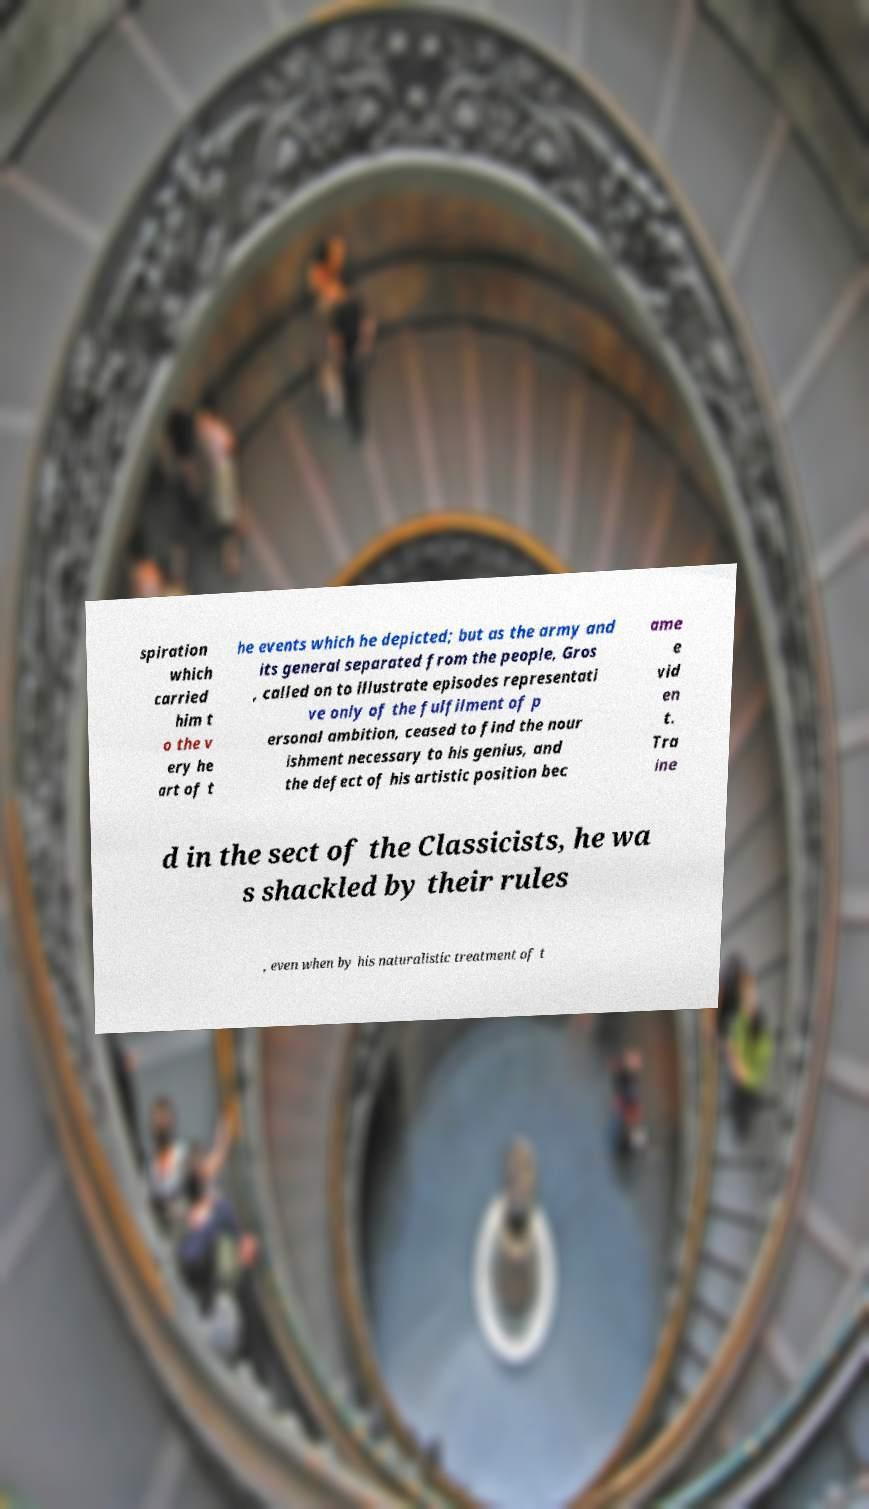Could you extract and type out the text from this image? spiration which carried him t o the v ery he art of t he events which he depicted; but as the army and its general separated from the people, Gros , called on to illustrate episodes representati ve only of the fulfilment of p ersonal ambition, ceased to find the nour ishment necessary to his genius, and the defect of his artistic position bec ame e vid en t. Tra ine d in the sect of the Classicists, he wa s shackled by their rules , even when by his naturalistic treatment of t 